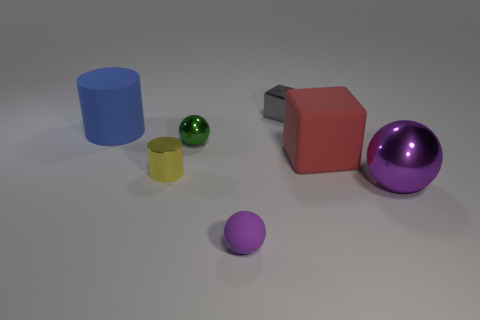Subtract all metallic balls. How many balls are left? 1 Add 1 large red metallic cylinders. How many objects exist? 8 Subtract all purple spheres. How many spheres are left? 1 Subtract 1 balls. How many balls are left? 2 Add 4 large balls. How many large balls are left? 5 Add 7 big yellow metallic things. How many big yellow metallic things exist? 7 Subtract 0 purple cylinders. How many objects are left? 7 Subtract all cylinders. How many objects are left? 5 Subtract all purple cubes. Subtract all blue cylinders. How many cubes are left? 2 Subtract all yellow blocks. How many blue cylinders are left? 1 